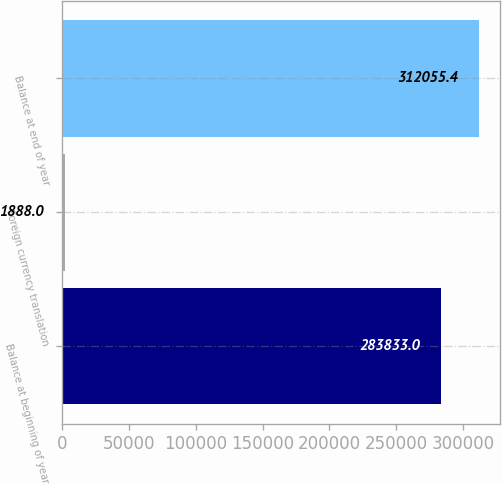<chart> <loc_0><loc_0><loc_500><loc_500><bar_chart><fcel>Balance at beginning of year<fcel>Foreign currency translation<fcel>Balance at end of year<nl><fcel>283833<fcel>1888<fcel>312055<nl></chart> 